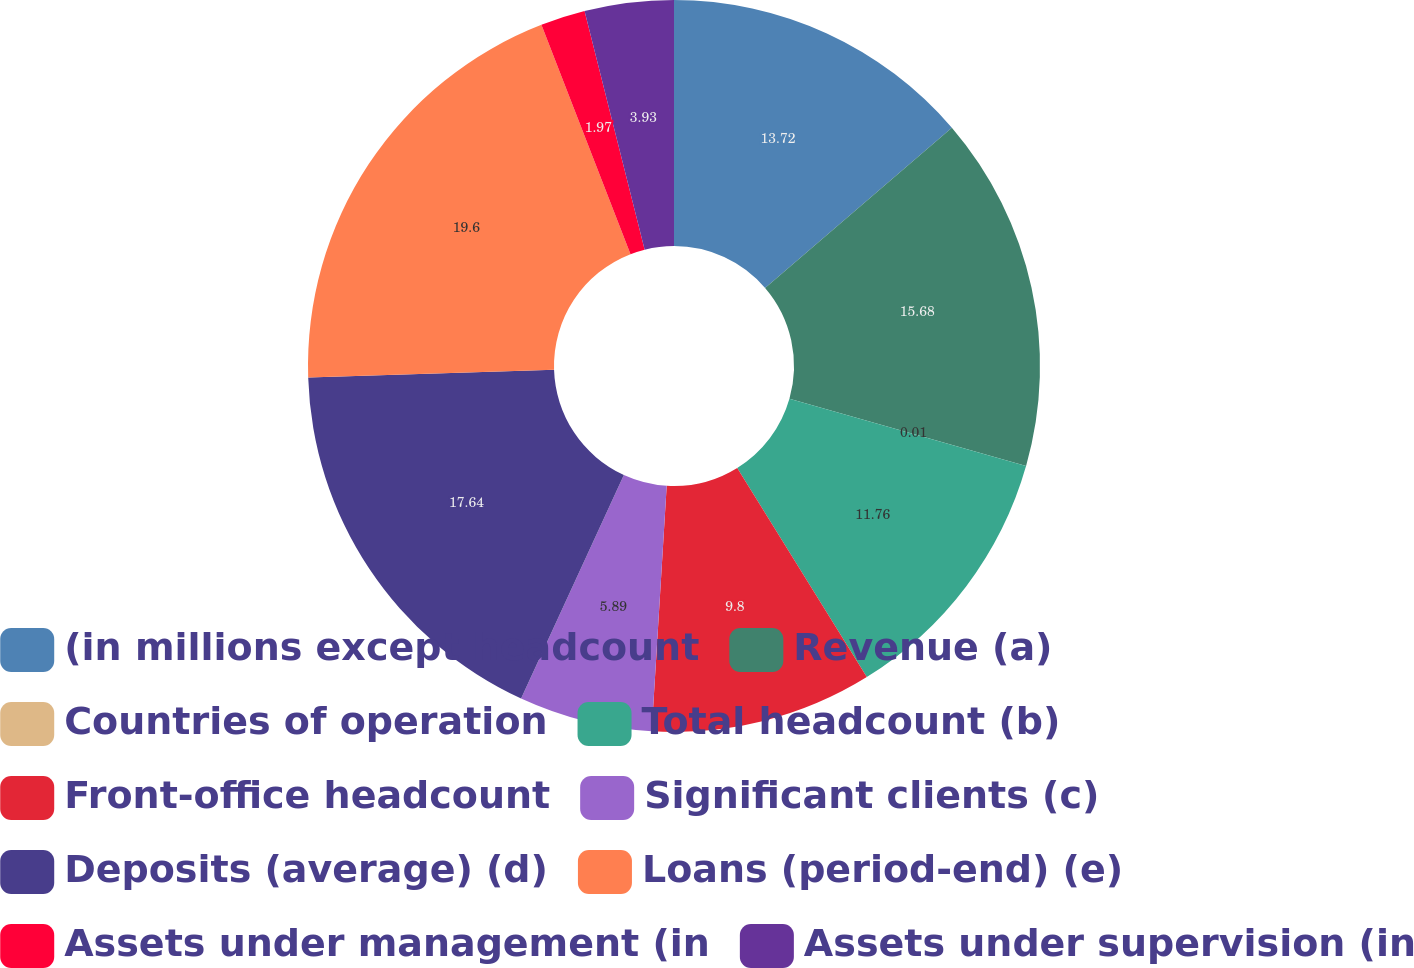Convert chart. <chart><loc_0><loc_0><loc_500><loc_500><pie_chart><fcel>(in millions except headcount<fcel>Revenue (a)<fcel>Countries of operation<fcel>Total headcount (b)<fcel>Front-office headcount<fcel>Significant clients (c)<fcel>Deposits (average) (d)<fcel>Loans (period-end) (e)<fcel>Assets under management (in<fcel>Assets under supervision (in<nl><fcel>13.72%<fcel>15.68%<fcel>0.01%<fcel>11.76%<fcel>9.8%<fcel>5.89%<fcel>17.64%<fcel>19.6%<fcel>1.97%<fcel>3.93%<nl></chart> 